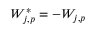<formula> <loc_0><loc_0><loc_500><loc_500>W _ { j , p } ^ { * } = - W _ { j , p }</formula> 